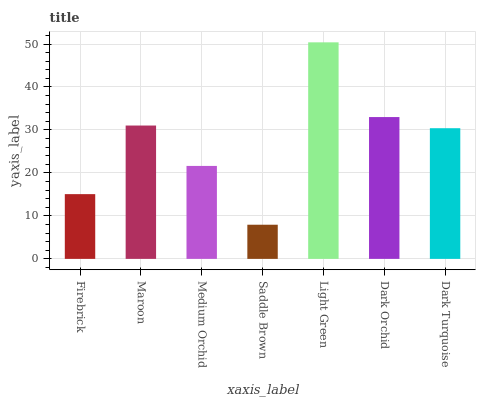Is Saddle Brown the minimum?
Answer yes or no. Yes. Is Light Green the maximum?
Answer yes or no. Yes. Is Maroon the minimum?
Answer yes or no. No. Is Maroon the maximum?
Answer yes or no. No. Is Maroon greater than Firebrick?
Answer yes or no. Yes. Is Firebrick less than Maroon?
Answer yes or no. Yes. Is Firebrick greater than Maroon?
Answer yes or no. No. Is Maroon less than Firebrick?
Answer yes or no. No. Is Dark Turquoise the high median?
Answer yes or no. Yes. Is Dark Turquoise the low median?
Answer yes or no. Yes. Is Dark Orchid the high median?
Answer yes or no. No. Is Dark Orchid the low median?
Answer yes or no. No. 